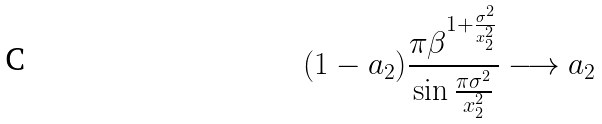Convert formula to latex. <formula><loc_0><loc_0><loc_500><loc_500>( 1 - a _ { 2 } ) \frac { \pi \beta ^ { 1 + \frac { \sigma ^ { 2 } } { x _ { 2 } ^ { 2 } } } } { \sin \frac { \pi \sigma ^ { 2 } } { x _ { 2 } ^ { 2 } } } \longrightarrow a _ { 2 }</formula> 